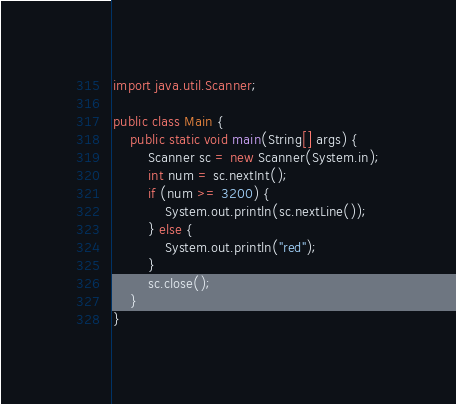Convert code to text. <code><loc_0><loc_0><loc_500><loc_500><_Java_>import java.util.Scanner;

public class Main {
    public static void main(String[] args) {
        Scanner sc = new Scanner(System.in);
        int num = sc.nextInt();
        if (num >= 3200) {
            System.out.println(sc.nextLine());
        } else {
            System.out.println("red");
        }
        sc.close();
    }
}</code> 